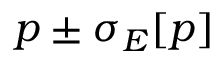Convert formula to latex. <formula><loc_0><loc_0><loc_500><loc_500>p \pm \sigma _ { E } [ p ]</formula> 